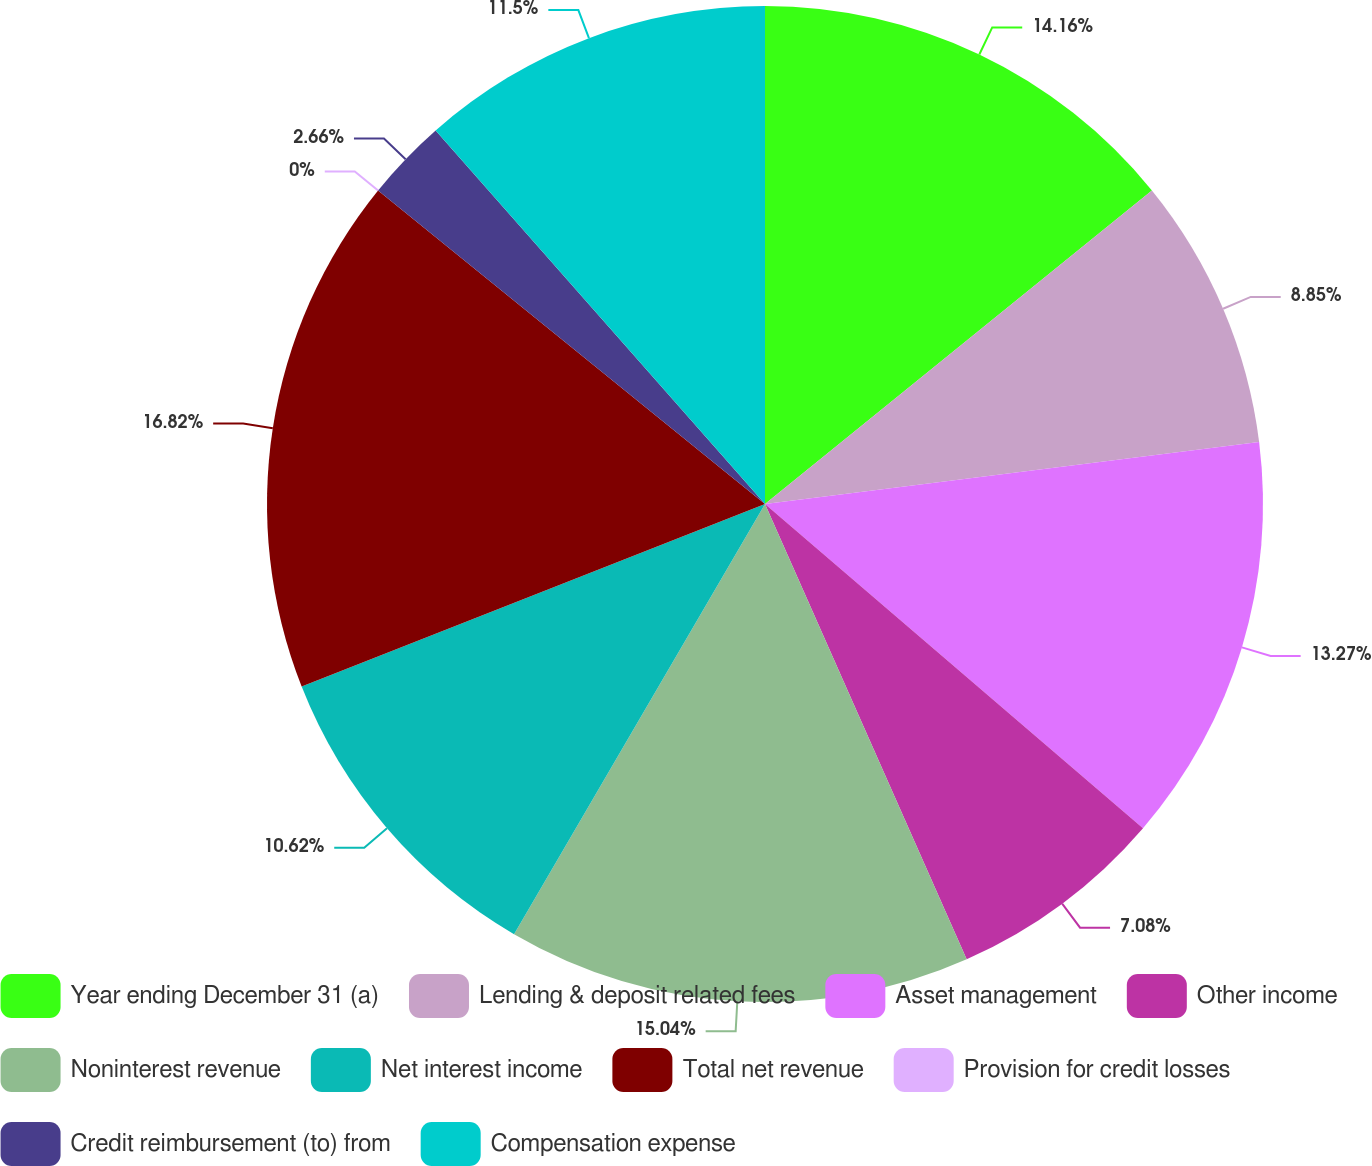Convert chart. <chart><loc_0><loc_0><loc_500><loc_500><pie_chart><fcel>Year ending December 31 (a)<fcel>Lending & deposit related fees<fcel>Asset management<fcel>Other income<fcel>Noninterest revenue<fcel>Net interest income<fcel>Total net revenue<fcel>Provision for credit losses<fcel>Credit reimbursement (to) from<fcel>Compensation expense<nl><fcel>14.16%<fcel>8.85%<fcel>13.27%<fcel>7.08%<fcel>15.04%<fcel>10.62%<fcel>16.81%<fcel>0.0%<fcel>2.66%<fcel>11.5%<nl></chart> 